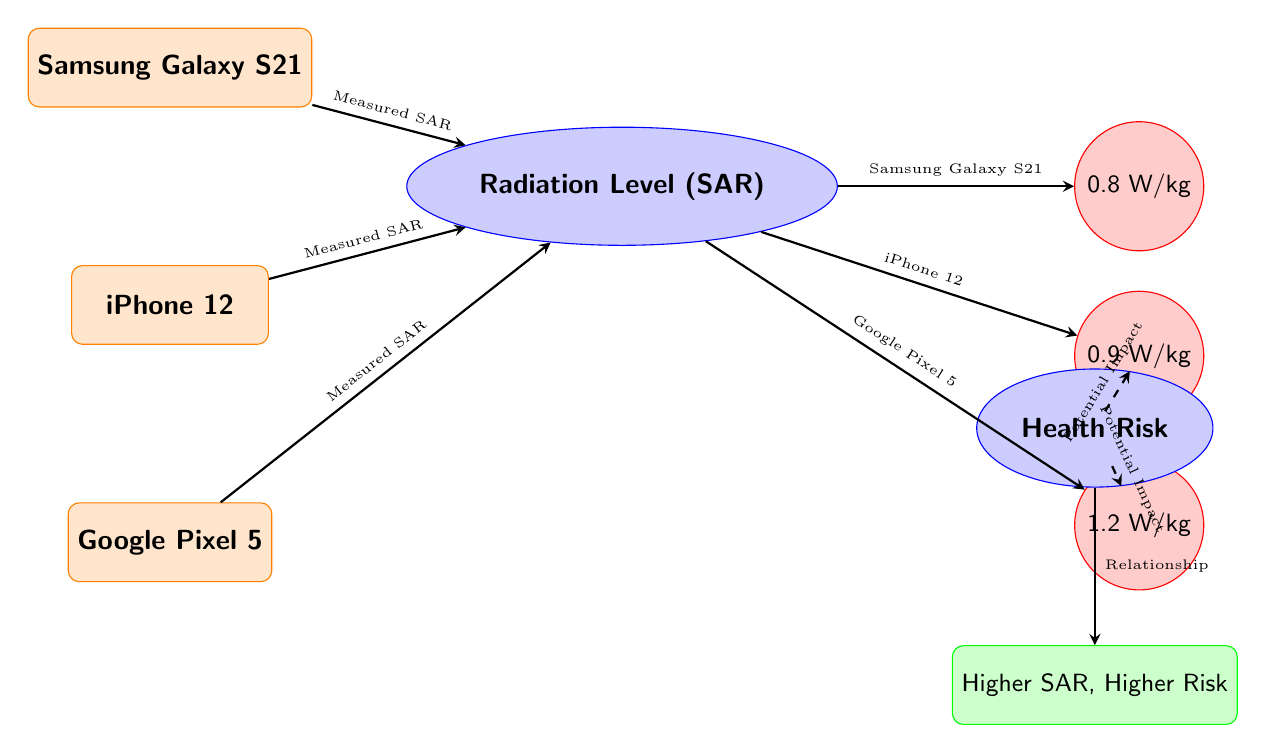What is the SAR level for the Samsung Galaxy S21? The diagram indicates that the measured SAR level for the Samsung Galaxy S21 is specifically noted as 0.8 W/kg.
Answer: 0.8 W/kg What does SAR stand for? The diagram does not explicitly define the acronym, but SAR commonly refers to Specific Absorption Rate in the context of radiation levels.
Answer: Specific Absorption Rate Which device has the highest SAR level? By comparing the SAR values presented in the diagram, it is clear that the Google Pixel 5 has the highest SAR level at 1.2 W/kg.
Answer: Google Pixel 5 What is the health risk associated with higher SAR levels? The diagram illustrates a direct relationship between radiation levels and health risks, stating that a higher SAR correlates with a higher risk; this is shown in the connection to the "Higher SAR, Higher Risk" concept.
Answer: Higher risk How many devices are compared in the diagram? The diagram explicitly lists three devices: Samsung Galaxy S21, iPhone 12, and Google Pixel 5, which makes a total of three devices being compared.
Answer: Three devices What is the SAR level for the iPhone 12? According to the diagram, the measured SAR level for the iPhone 12 is indicated as 0.9 W/kg.
Answer: 0.9 W/kg What type of relationship does the diagram suggest between SAR levels and health risk? The diagram depicts a clear relationship, indicating that with an increase in SAR levels, there is a corresponding increase in health risks. This relationship is represented visually through the arrows connecting these concepts.
Answer: Direct relationship What does the concept node indicate about SAR and health risk? The concept node states "Higher SAR, Higher Risk," suggesting that as the SAR levels increase, so does the associated health risk.
Answer: Higher SAR, Higher Risk What is the SAR level for the Google Pixel 5? The diagram specifies that the SAR level for the Google Pixel 5 is measured at 1.2 W/kg.
Answer: 1.2 W/kg 